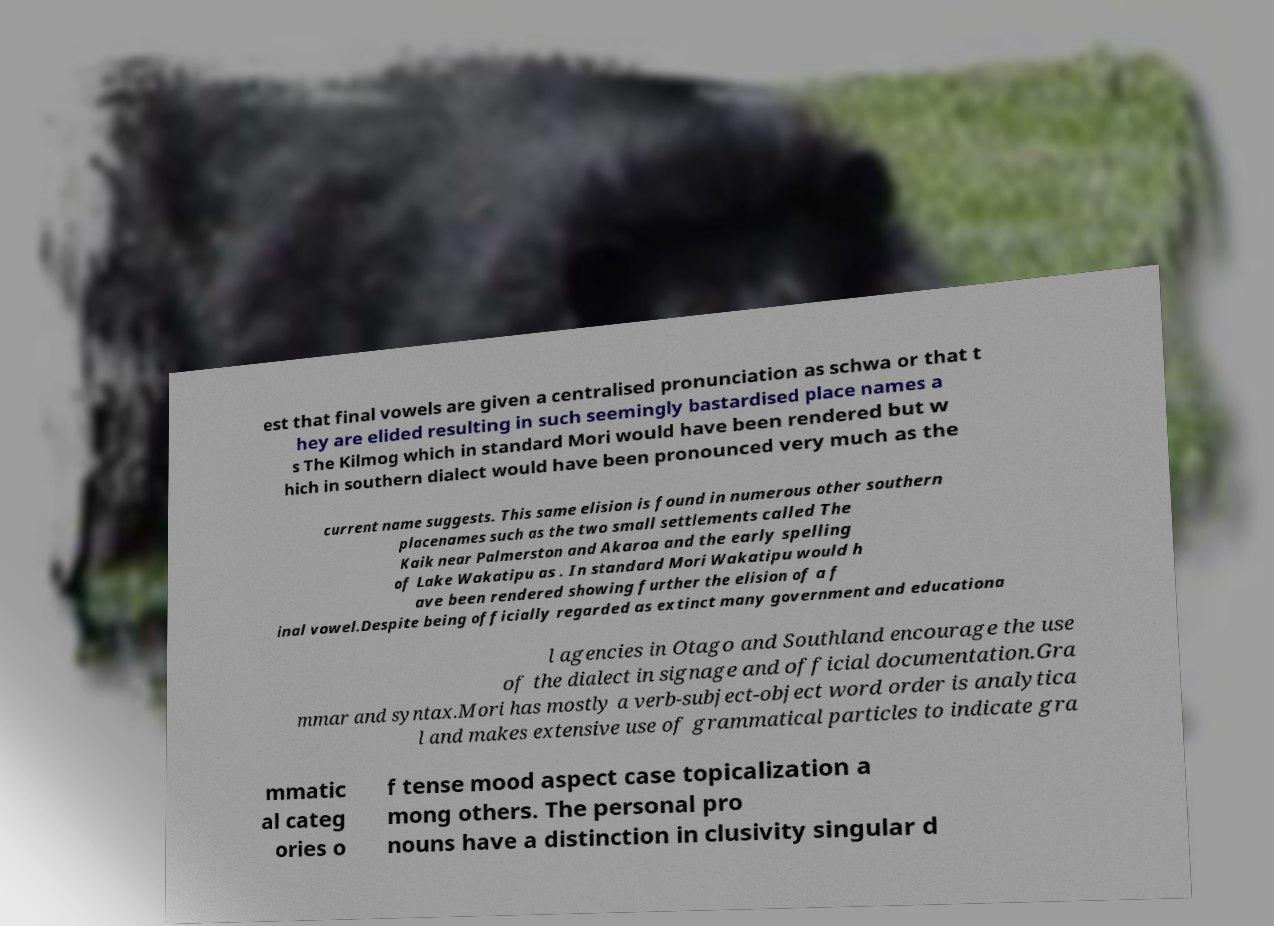Could you assist in decoding the text presented in this image and type it out clearly? est that final vowels are given a centralised pronunciation as schwa or that t hey are elided resulting in such seemingly bastardised place names a s The Kilmog which in standard Mori would have been rendered but w hich in southern dialect would have been pronounced very much as the current name suggests. This same elision is found in numerous other southern placenames such as the two small settlements called The Kaik near Palmerston and Akaroa and the early spelling of Lake Wakatipu as . In standard Mori Wakatipu would h ave been rendered showing further the elision of a f inal vowel.Despite being officially regarded as extinct many government and educationa l agencies in Otago and Southland encourage the use of the dialect in signage and official documentation.Gra mmar and syntax.Mori has mostly a verb-subject-object word order is analytica l and makes extensive use of grammatical particles to indicate gra mmatic al categ ories o f tense mood aspect case topicalization a mong others. The personal pro nouns have a distinction in clusivity singular d 